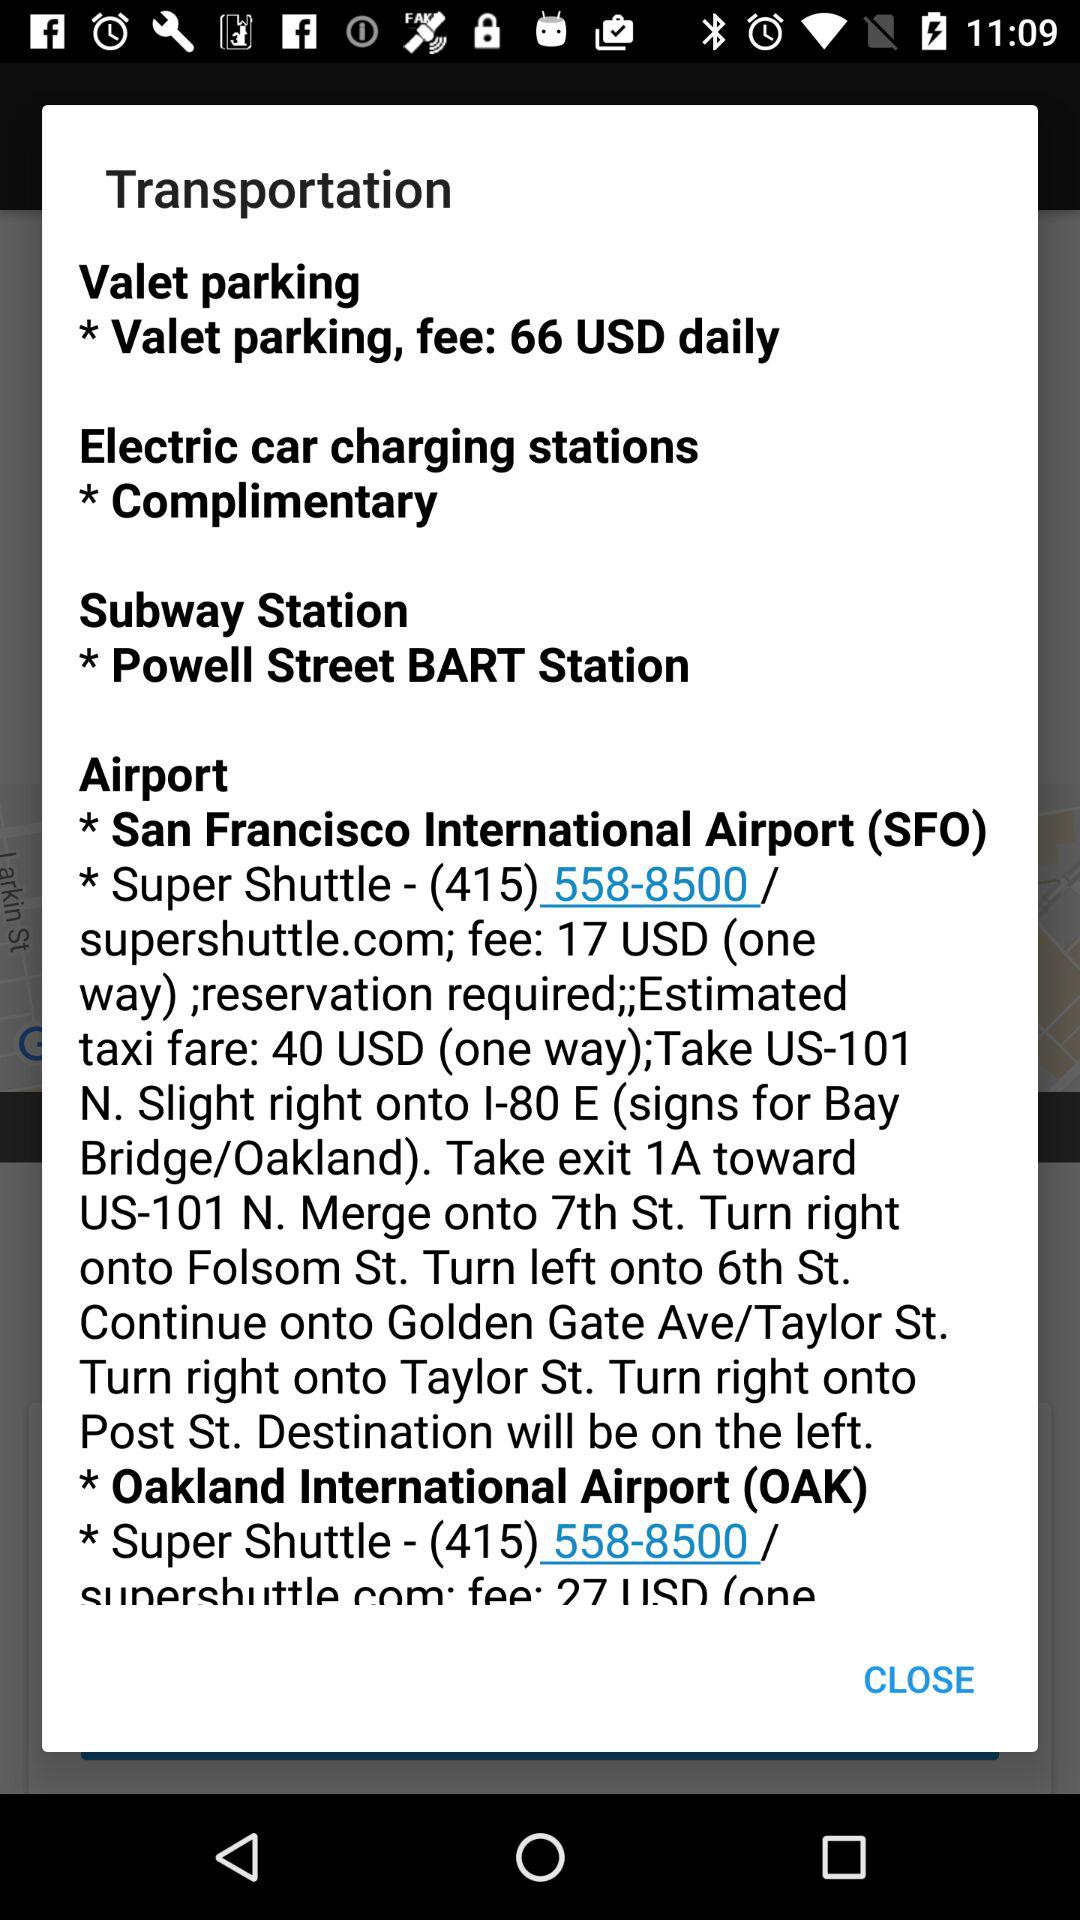What is the valet parking fee per day? The per-day valet parking fee is $66. 